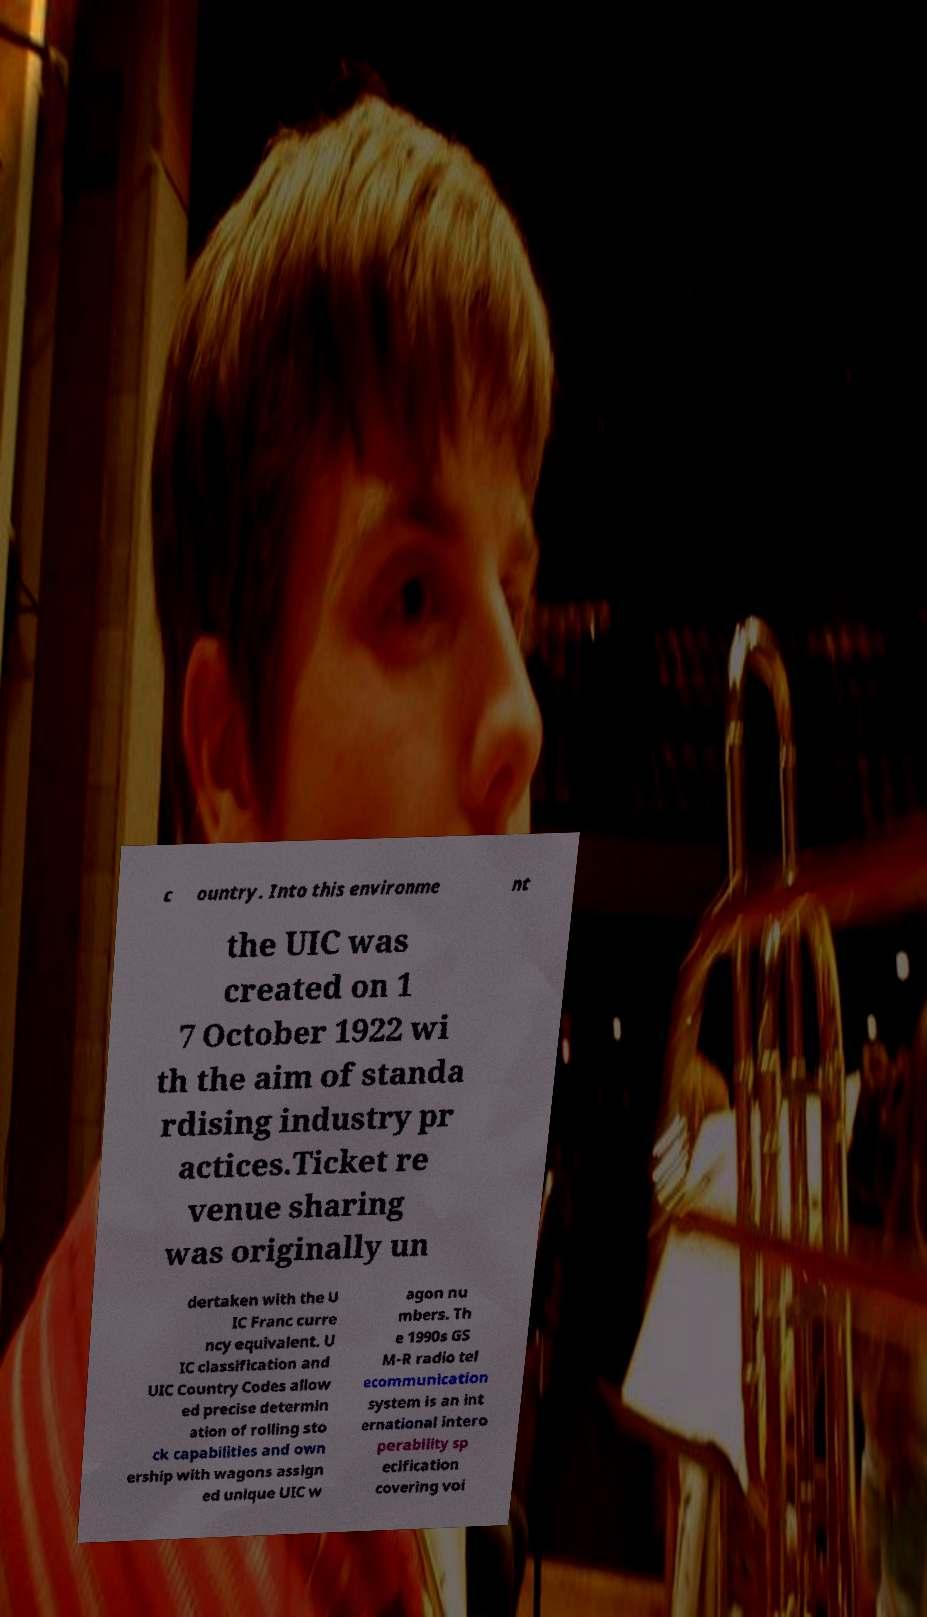For documentation purposes, I need the text within this image transcribed. Could you provide that? c ountry. Into this environme nt the UIC was created on 1 7 October 1922 wi th the aim of standa rdising industry pr actices.Ticket re venue sharing was originally un dertaken with the U IC Franc curre ncy equivalent. U IC classification and UIC Country Codes allow ed precise determin ation of rolling sto ck capabilities and own ership with wagons assign ed unique UIC w agon nu mbers. Th e 1990s GS M-R radio tel ecommunication system is an int ernational intero perability sp ecification covering voi 